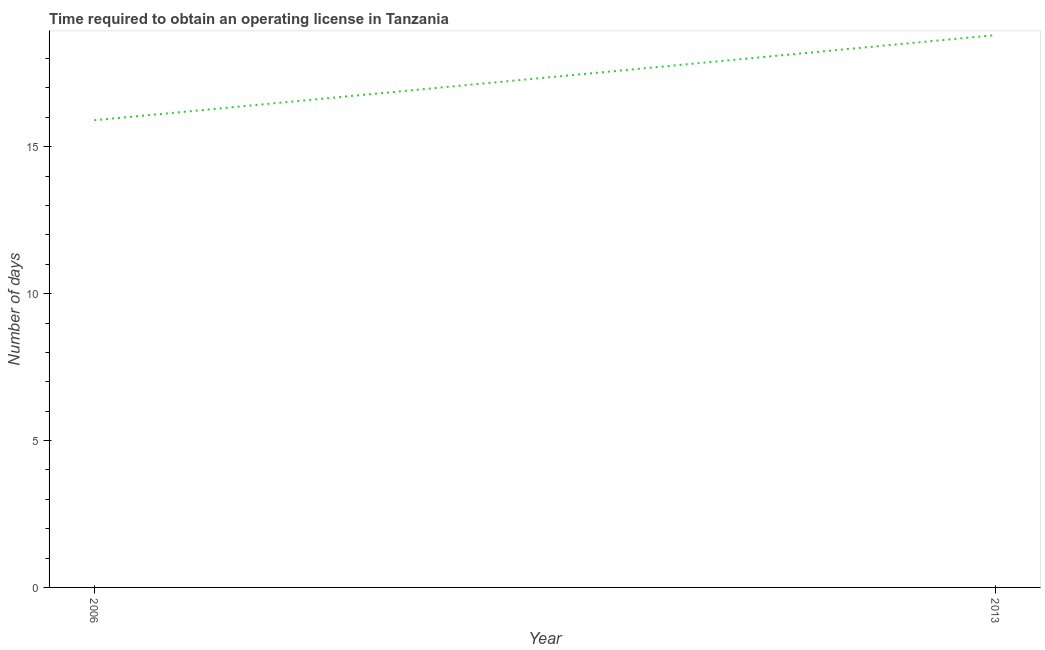What is the number of days to obtain operating license in 2013?
Keep it short and to the point. 18.8. What is the sum of the number of days to obtain operating license?
Your answer should be compact. 34.7. What is the difference between the number of days to obtain operating license in 2006 and 2013?
Make the answer very short. -2.9. What is the average number of days to obtain operating license per year?
Make the answer very short. 17.35. What is the median number of days to obtain operating license?
Provide a short and direct response. 17.35. What is the ratio of the number of days to obtain operating license in 2006 to that in 2013?
Provide a succinct answer. 0.85. Is the number of days to obtain operating license in 2006 less than that in 2013?
Keep it short and to the point. Yes. In how many years, is the number of days to obtain operating license greater than the average number of days to obtain operating license taken over all years?
Provide a short and direct response. 1. Does the number of days to obtain operating license monotonically increase over the years?
Ensure brevity in your answer.  Yes. How many years are there in the graph?
Offer a terse response. 2. What is the difference between two consecutive major ticks on the Y-axis?
Offer a terse response. 5. Are the values on the major ticks of Y-axis written in scientific E-notation?
Provide a succinct answer. No. What is the title of the graph?
Offer a very short reply. Time required to obtain an operating license in Tanzania. What is the label or title of the X-axis?
Your response must be concise. Year. What is the label or title of the Y-axis?
Provide a short and direct response. Number of days. What is the Number of days in 2013?
Make the answer very short. 18.8. What is the difference between the Number of days in 2006 and 2013?
Provide a succinct answer. -2.9. What is the ratio of the Number of days in 2006 to that in 2013?
Make the answer very short. 0.85. 